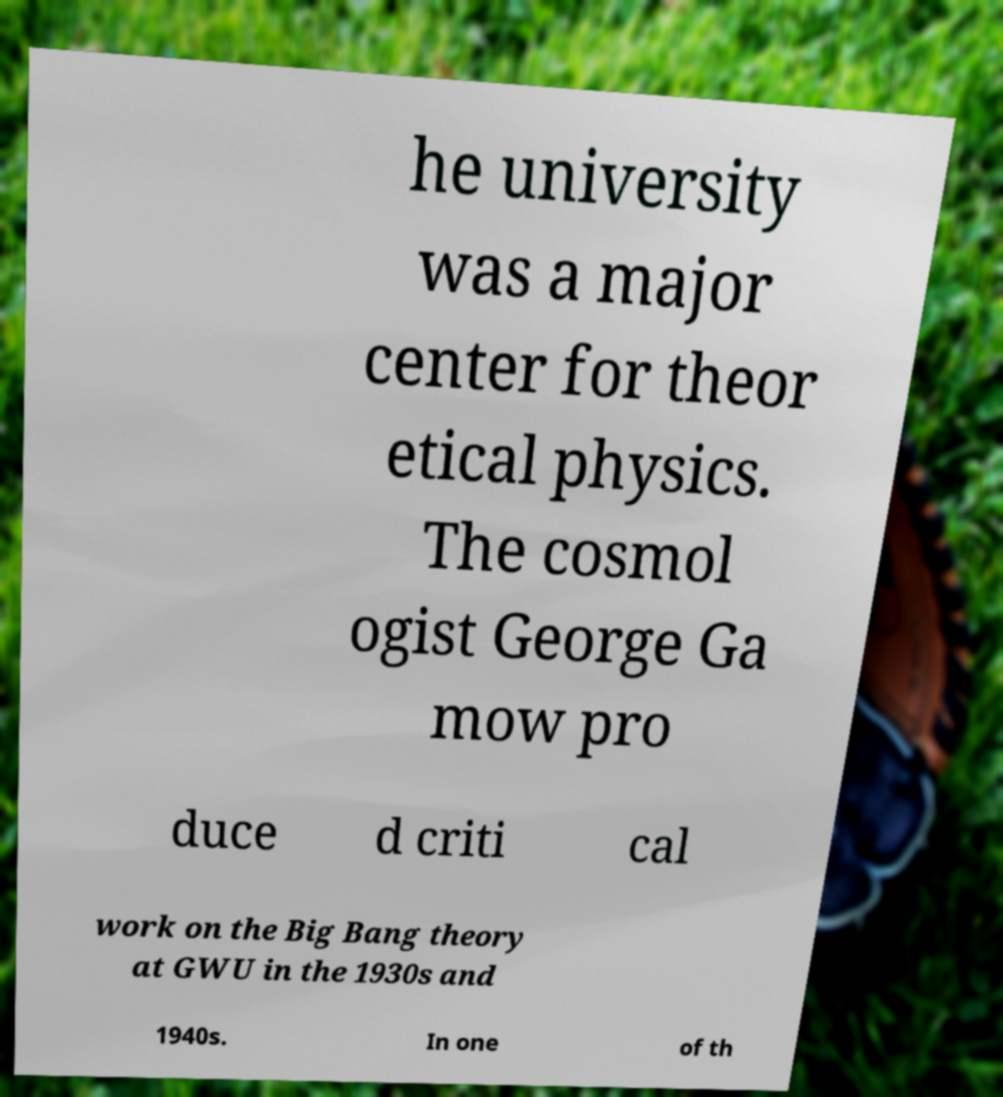Can you accurately transcribe the text from the provided image for me? he university was a major center for theor etical physics. The cosmol ogist George Ga mow pro duce d criti cal work on the Big Bang theory at GWU in the 1930s and 1940s. In one of th 